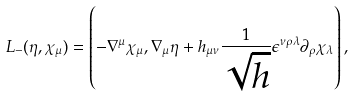<formula> <loc_0><loc_0><loc_500><loc_500>L _ { - } ( \eta , \chi _ { \mu } ) = \left ( - \nabla ^ { \mu } \chi _ { \mu } , \nabla _ { \mu } \eta + h _ { \mu \nu } \frac { 1 } { \sqrt { h } } \epsilon ^ { \nu \rho \lambda } \partial _ { \rho } \chi _ { \lambda } \right ) ,</formula> 